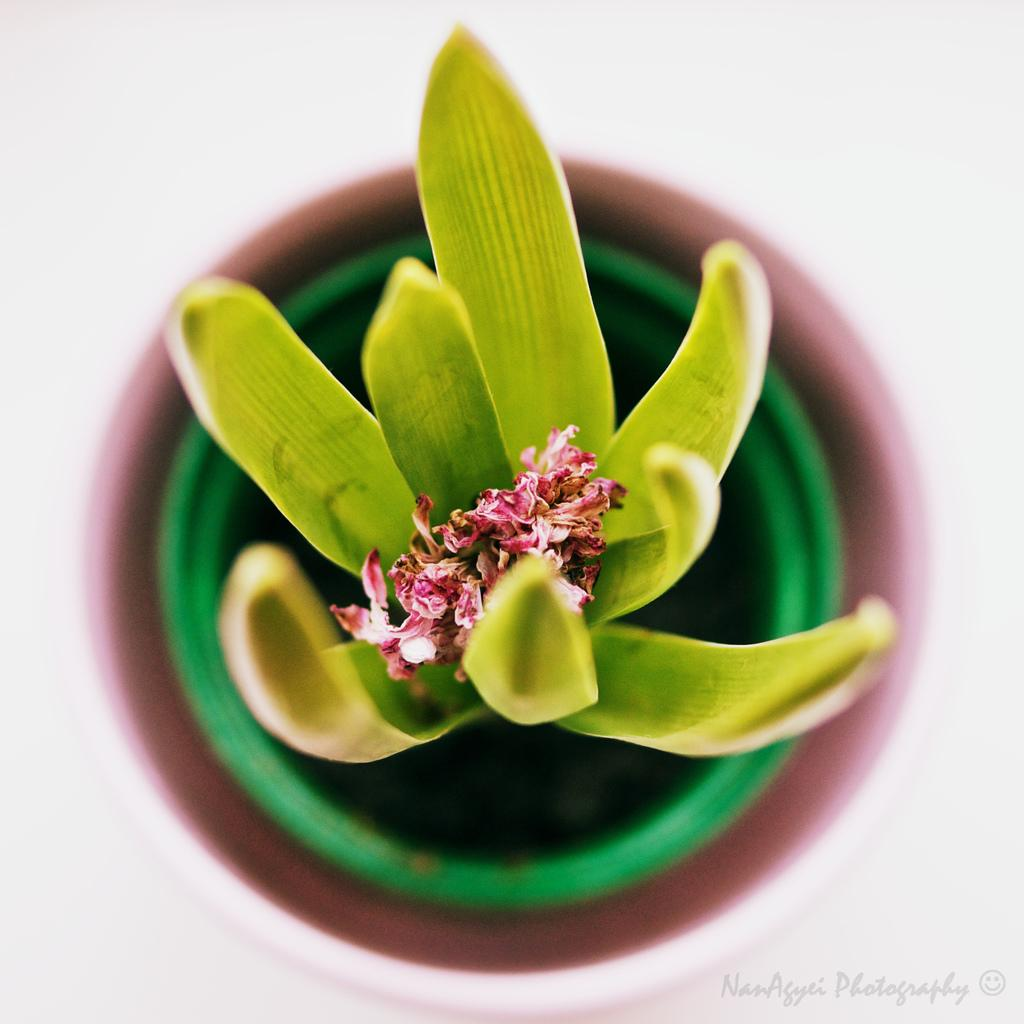What type of plant is in the image? There is a flower plant in a pot in the image. What is the color of the surface in the image? The surface in the image is white. Where is the watermark located in the image? The watermark is in the right corner bottom of the image. What type of coal is being used for the journey in the image? There is no coal or journey present in the image; it features a flower plant in a pot on a white surface with a watermark. 